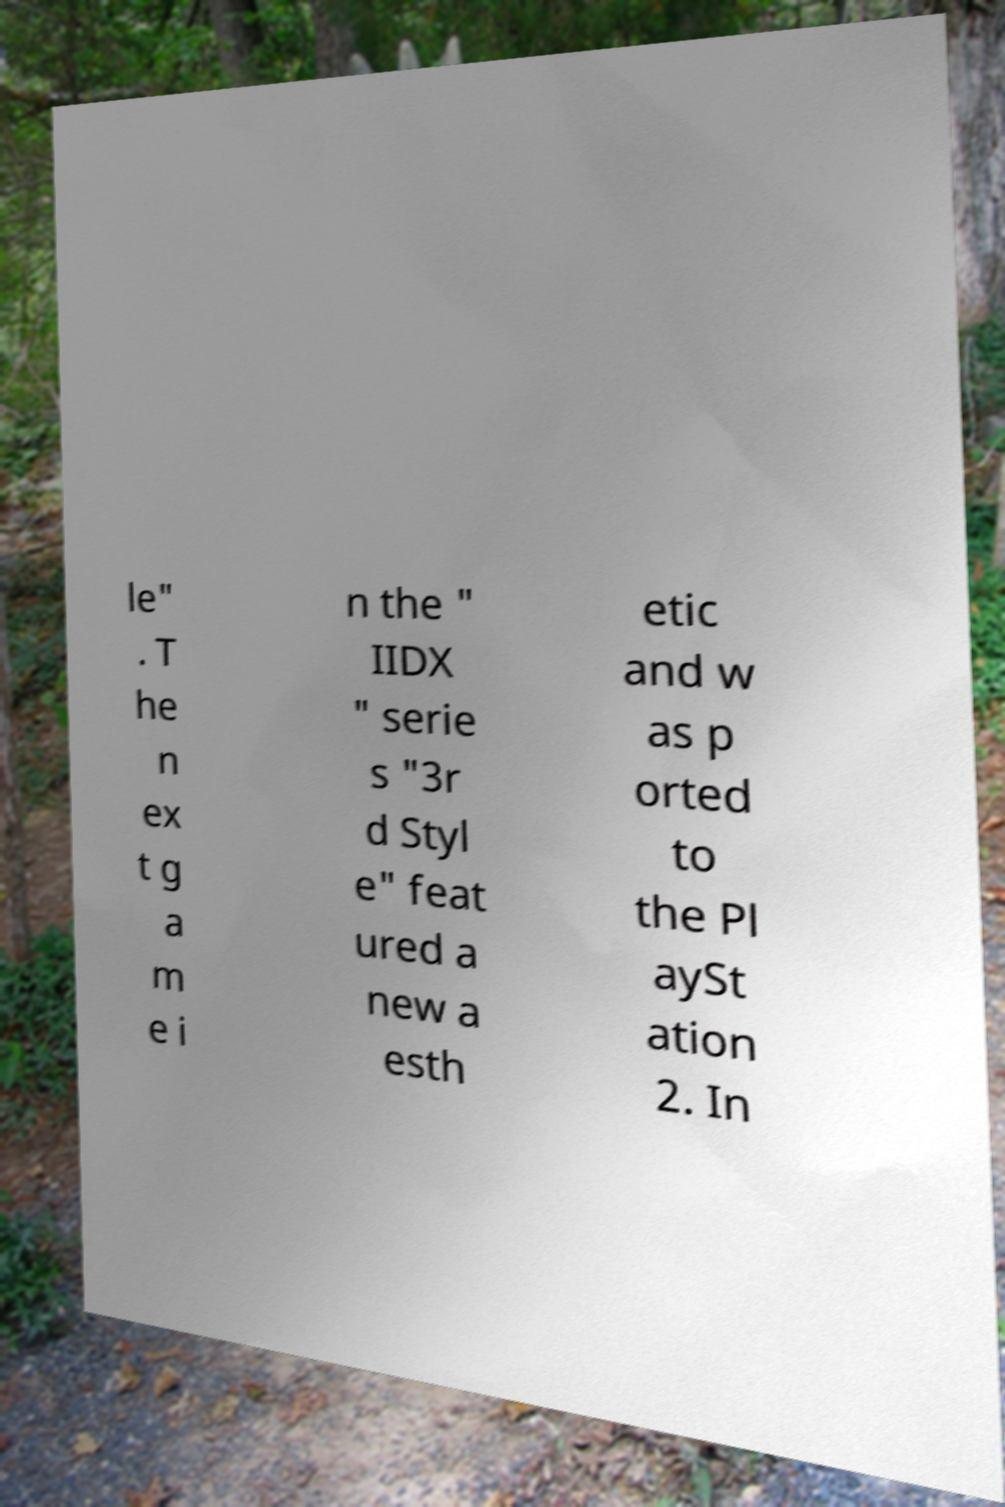Can you read and provide the text displayed in the image?This photo seems to have some interesting text. Can you extract and type it out for me? le" . T he n ex t g a m e i n the " IIDX " serie s "3r d Styl e" feat ured a new a esth etic and w as p orted to the Pl aySt ation 2. In 